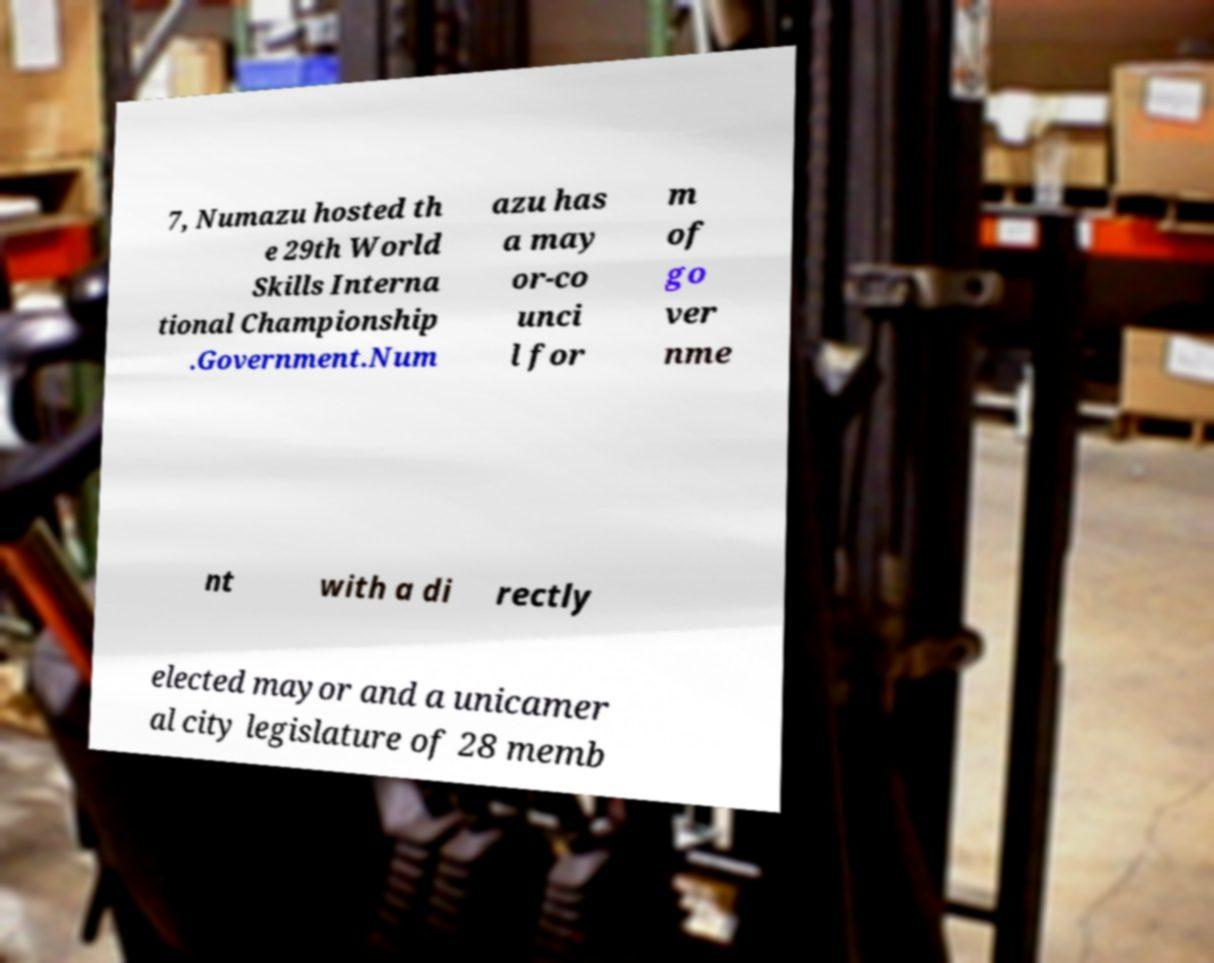For documentation purposes, I need the text within this image transcribed. Could you provide that? 7, Numazu hosted th e 29th World Skills Interna tional Championship .Government.Num azu has a may or-co unci l for m of go ver nme nt with a di rectly elected mayor and a unicamer al city legislature of 28 memb 